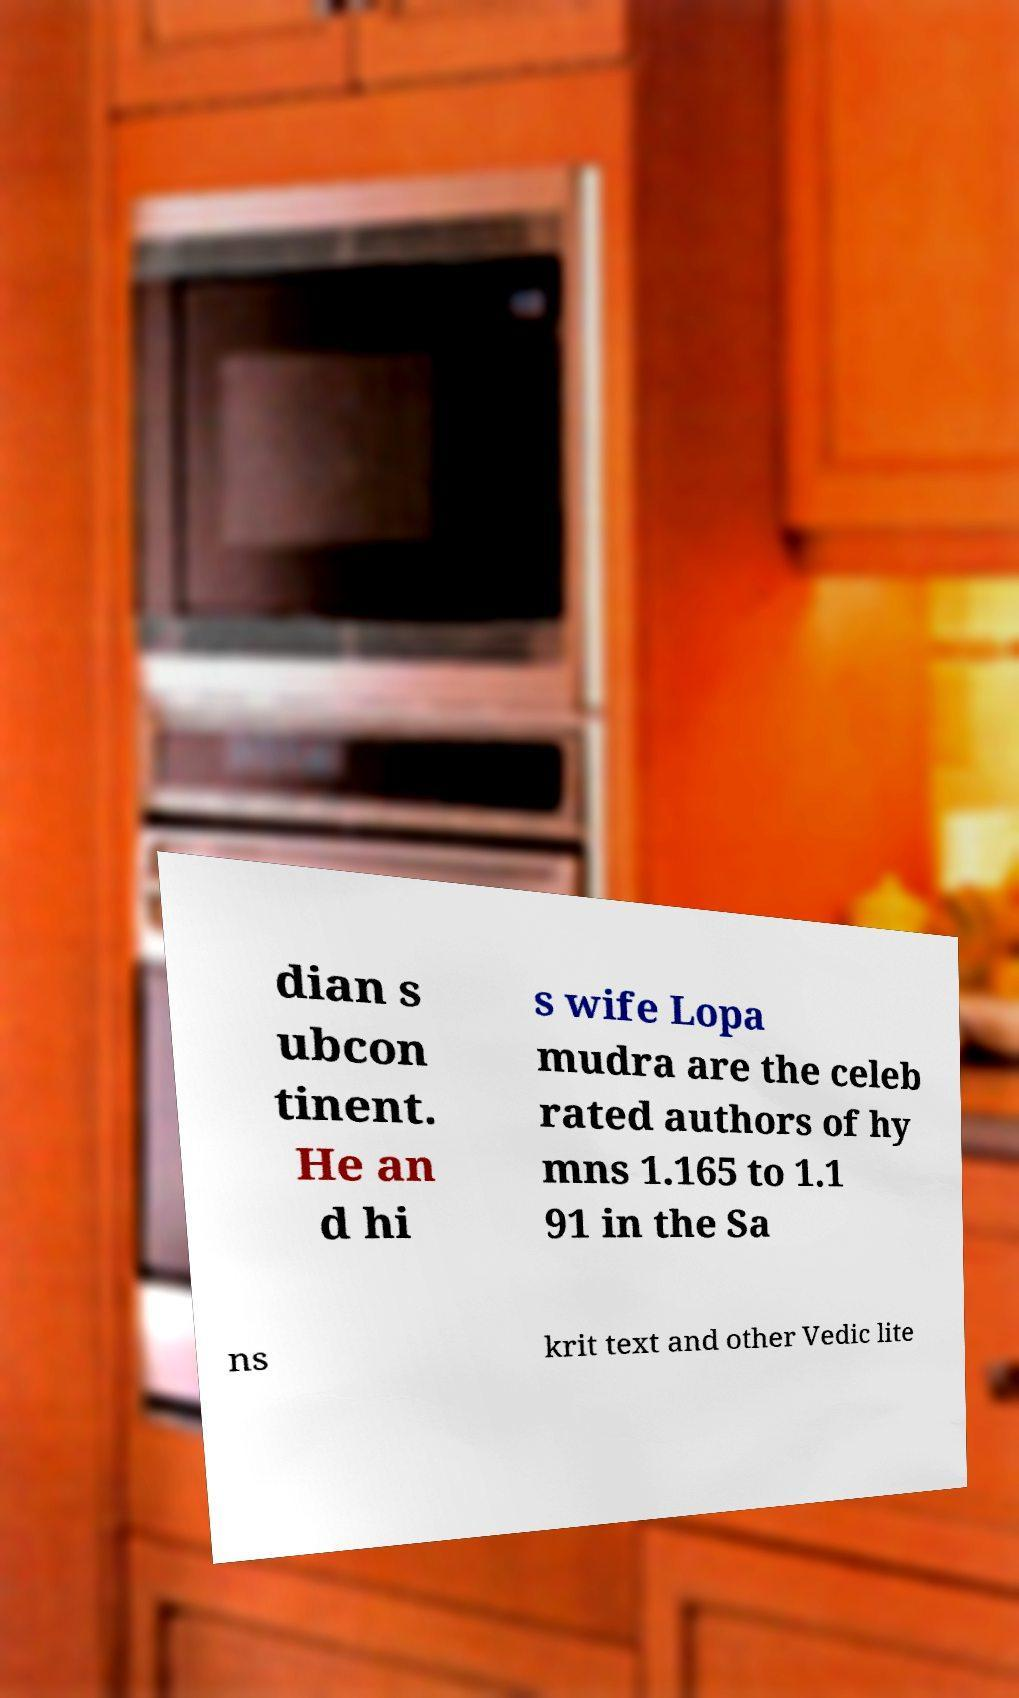Could you extract and type out the text from this image? dian s ubcon tinent. He an d hi s wife Lopa mudra are the celeb rated authors of hy mns 1.165 to 1.1 91 in the Sa ns krit text and other Vedic lite 